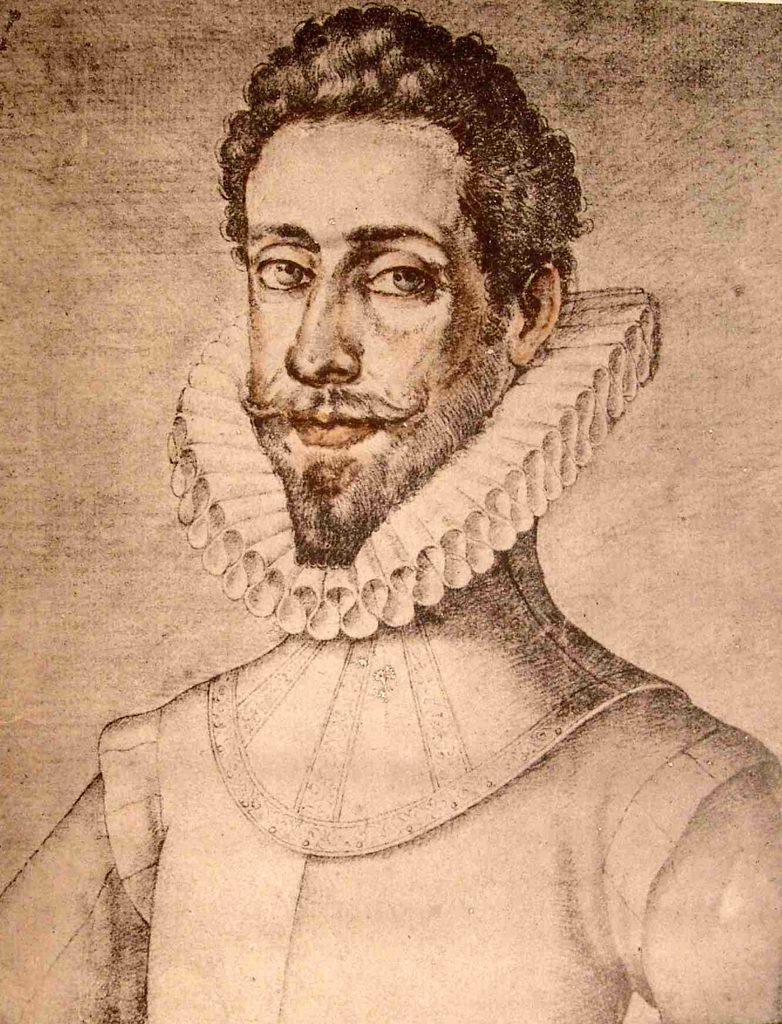Please provide a concise description of this image. In this image I can see depiction of a man. I can see this image is little bit brown and white in colour. 